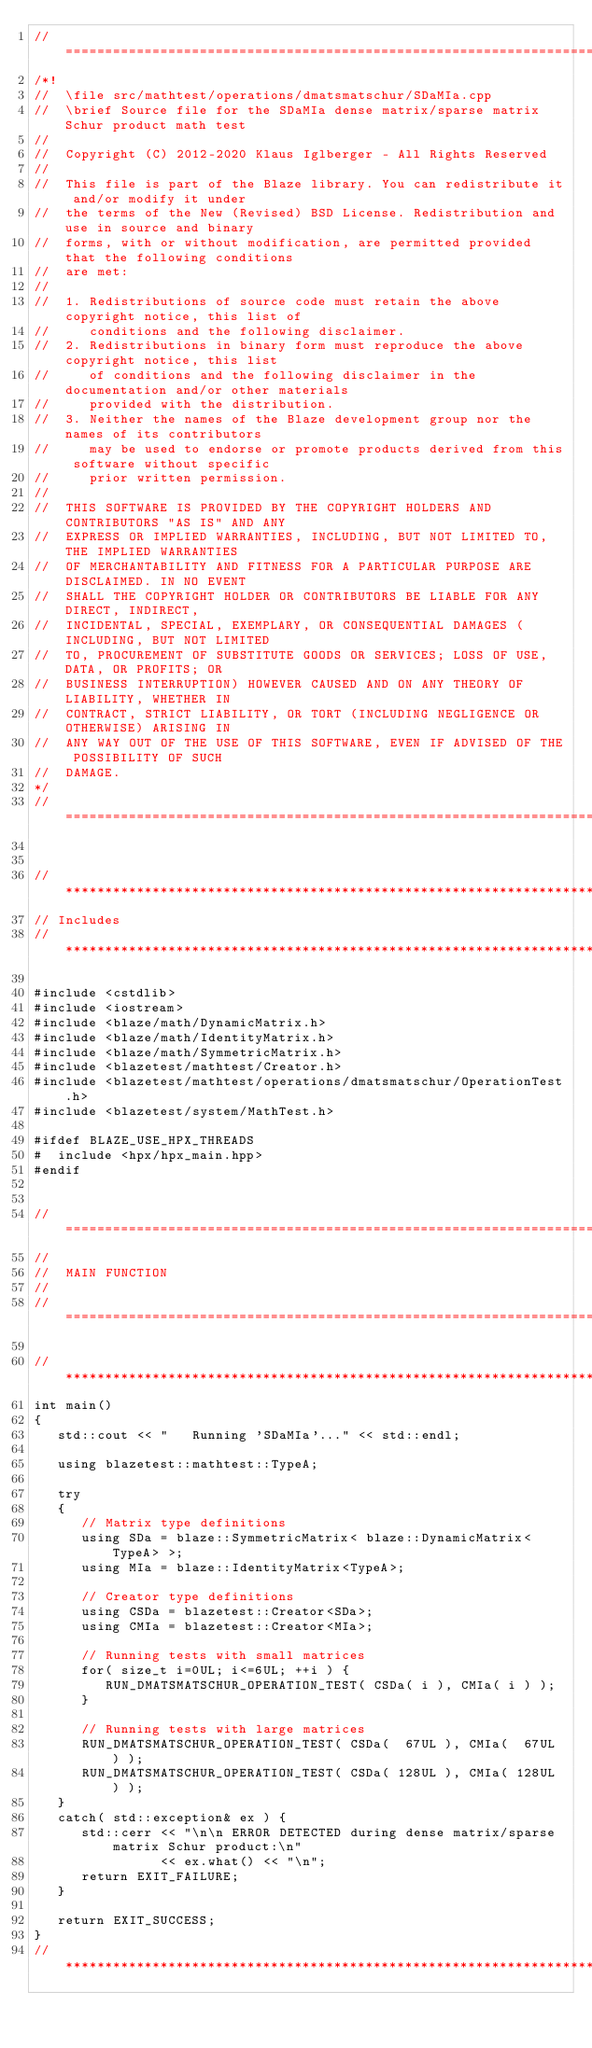<code> <loc_0><loc_0><loc_500><loc_500><_C++_>//=================================================================================================
/*!
//  \file src/mathtest/operations/dmatsmatschur/SDaMIa.cpp
//  \brief Source file for the SDaMIa dense matrix/sparse matrix Schur product math test
//
//  Copyright (C) 2012-2020 Klaus Iglberger - All Rights Reserved
//
//  This file is part of the Blaze library. You can redistribute it and/or modify it under
//  the terms of the New (Revised) BSD License. Redistribution and use in source and binary
//  forms, with or without modification, are permitted provided that the following conditions
//  are met:
//
//  1. Redistributions of source code must retain the above copyright notice, this list of
//     conditions and the following disclaimer.
//  2. Redistributions in binary form must reproduce the above copyright notice, this list
//     of conditions and the following disclaimer in the documentation and/or other materials
//     provided with the distribution.
//  3. Neither the names of the Blaze development group nor the names of its contributors
//     may be used to endorse or promote products derived from this software without specific
//     prior written permission.
//
//  THIS SOFTWARE IS PROVIDED BY THE COPYRIGHT HOLDERS AND CONTRIBUTORS "AS IS" AND ANY
//  EXPRESS OR IMPLIED WARRANTIES, INCLUDING, BUT NOT LIMITED TO, THE IMPLIED WARRANTIES
//  OF MERCHANTABILITY AND FITNESS FOR A PARTICULAR PURPOSE ARE DISCLAIMED. IN NO EVENT
//  SHALL THE COPYRIGHT HOLDER OR CONTRIBUTORS BE LIABLE FOR ANY DIRECT, INDIRECT,
//  INCIDENTAL, SPECIAL, EXEMPLARY, OR CONSEQUENTIAL DAMAGES (INCLUDING, BUT NOT LIMITED
//  TO, PROCUREMENT OF SUBSTITUTE GOODS OR SERVICES; LOSS OF USE, DATA, OR PROFITS; OR
//  BUSINESS INTERRUPTION) HOWEVER CAUSED AND ON ANY THEORY OF LIABILITY, WHETHER IN
//  CONTRACT, STRICT LIABILITY, OR TORT (INCLUDING NEGLIGENCE OR OTHERWISE) ARISING IN
//  ANY WAY OUT OF THE USE OF THIS SOFTWARE, EVEN IF ADVISED OF THE POSSIBILITY OF SUCH
//  DAMAGE.
*/
//=================================================================================================


//*************************************************************************************************
// Includes
//*************************************************************************************************

#include <cstdlib>
#include <iostream>
#include <blaze/math/DynamicMatrix.h>
#include <blaze/math/IdentityMatrix.h>
#include <blaze/math/SymmetricMatrix.h>
#include <blazetest/mathtest/Creator.h>
#include <blazetest/mathtest/operations/dmatsmatschur/OperationTest.h>
#include <blazetest/system/MathTest.h>

#ifdef BLAZE_USE_HPX_THREADS
#  include <hpx/hpx_main.hpp>
#endif


//=================================================================================================
//
//  MAIN FUNCTION
//
//=================================================================================================

//*************************************************************************************************
int main()
{
   std::cout << "   Running 'SDaMIa'..." << std::endl;

   using blazetest::mathtest::TypeA;

   try
   {
      // Matrix type definitions
      using SDa = blaze::SymmetricMatrix< blaze::DynamicMatrix<TypeA> >;
      using MIa = blaze::IdentityMatrix<TypeA>;

      // Creator type definitions
      using CSDa = blazetest::Creator<SDa>;
      using CMIa = blazetest::Creator<MIa>;

      // Running tests with small matrices
      for( size_t i=0UL; i<=6UL; ++i ) {
         RUN_DMATSMATSCHUR_OPERATION_TEST( CSDa( i ), CMIa( i ) );
      }

      // Running tests with large matrices
      RUN_DMATSMATSCHUR_OPERATION_TEST( CSDa(  67UL ), CMIa(  67UL ) );
      RUN_DMATSMATSCHUR_OPERATION_TEST( CSDa( 128UL ), CMIa( 128UL ) );
   }
   catch( std::exception& ex ) {
      std::cerr << "\n\n ERROR DETECTED during dense matrix/sparse matrix Schur product:\n"
                << ex.what() << "\n";
      return EXIT_FAILURE;
   }

   return EXIT_SUCCESS;
}
//*************************************************************************************************
</code> 